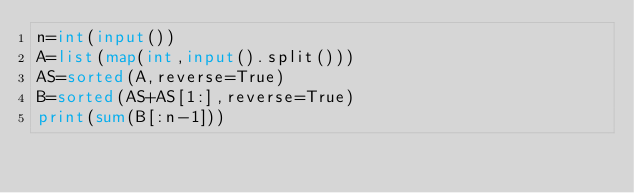<code> <loc_0><loc_0><loc_500><loc_500><_Python_>n=int(input())
A=list(map(int,input().split()))
AS=sorted(A,reverse=True)
B=sorted(AS+AS[1:],reverse=True)
print(sum(B[:n-1]))</code> 